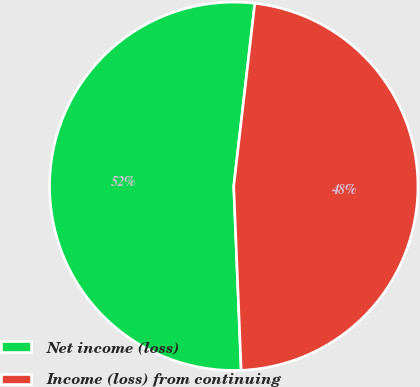Convert chart. <chart><loc_0><loc_0><loc_500><loc_500><pie_chart><fcel>Net income (loss)<fcel>Income (loss) from continuing<nl><fcel>52.47%<fcel>47.53%<nl></chart> 